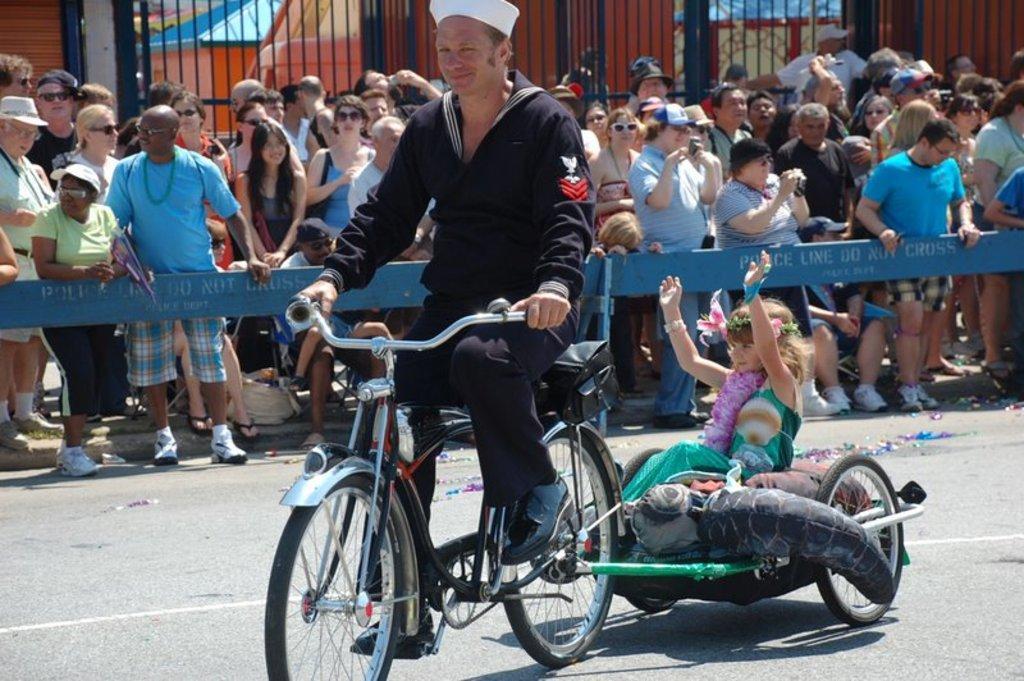How would you summarize this image in a sentence or two? In this image I can see a number of people where a man is cycling his cycle. I can also see a girl is sitting here. 